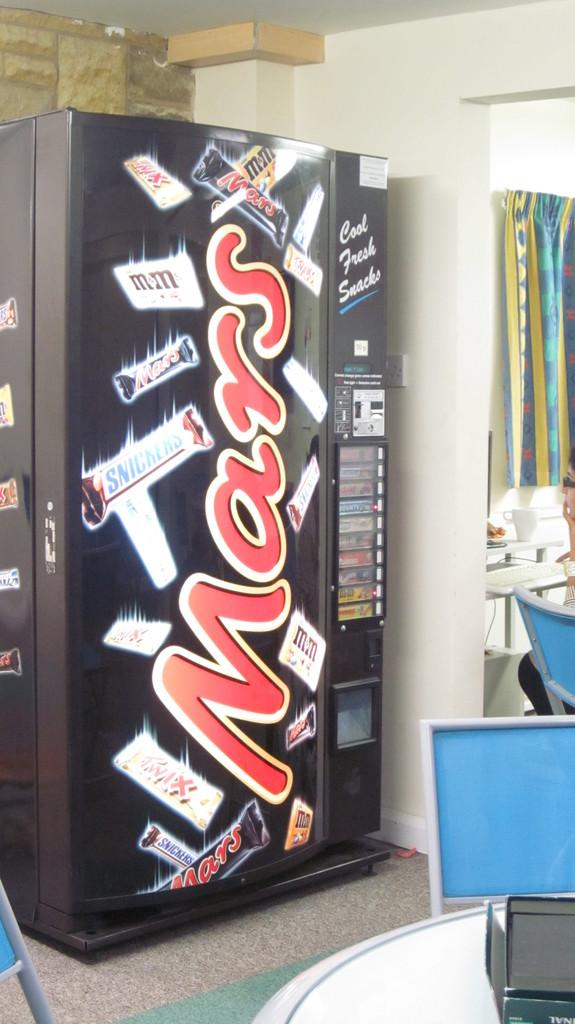<image>
Give a short and clear explanation of the subsequent image. The Mars Corporation name is visible in huge letters on a vending machine. 